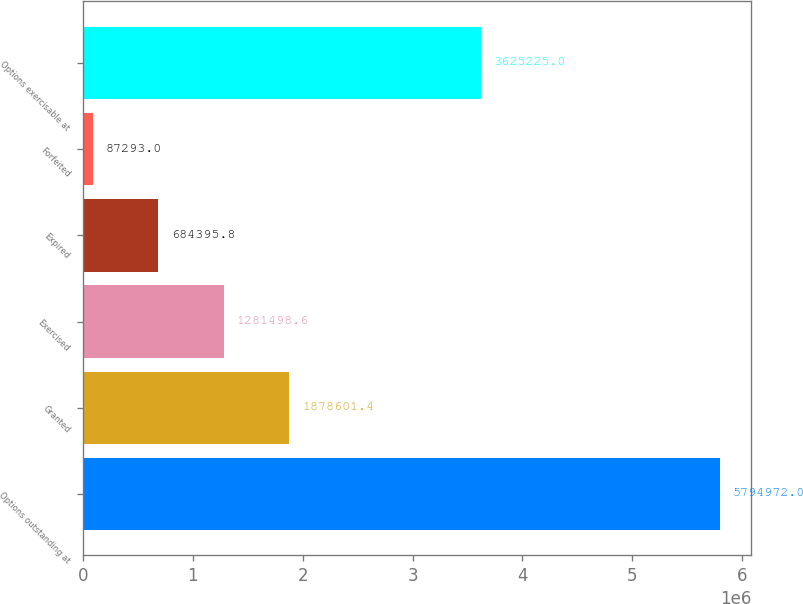Convert chart to OTSL. <chart><loc_0><loc_0><loc_500><loc_500><bar_chart><fcel>Options outstanding at<fcel>Granted<fcel>Exercised<fcel>Expired<fcel>Forfeited<fcel>Options exercisable at<nl><fcel>5.79497e+06<fcel>1.8786e+06<fcel>1.2815e+06<fcel>684396<fcel>87293<fcel>3.62522e+06<nl></chart> 